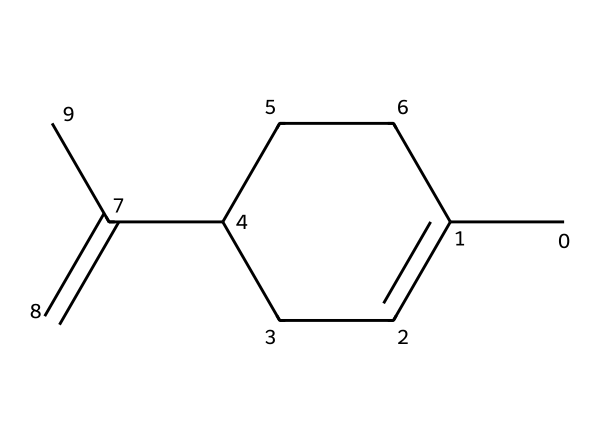What is the name of this compound? The SMILES representation corresponds to limonene, a well-known terpene found in citrus fruits, which is often associated with its characteristic citrus scent.
Answer: limonene How many carbon atoms are in limonene? Analyzing the structure based on the SMILES, there are a total of 10 carbon atoms present in the molecular structure of limonene.
Answer: 10 Is limonene chiral? The presence of a chiral center in the structure can be identified by looking for a carbon atom attached to four different substituents; limonene has one such carbon, confirming its chirality.
Answer: Yes What type of compound is limonene? Limonene is classified as a terpene, which is a category of compounds made primarily of carbon and hydrogen, commonly found in essential oils from plants.
Answer: terpene How many double bonds are present in limonene? The SMILES structure reveals that limonene contains two double bonds, which affect its chemical properties and reactivity.
Answer: 2 What functional group is present in limonene? Examining the structure, we can see that limonene does not contain an alcohol or carbonyl group; rather, it is a hydrocarbon with double bonds, characteristic of terpenes.
Answer: none What is the molecular formula of limonene? From counting the carbon and hydrogen atoms in the structure, the molecular formula can be derived as C10H16 for limonene.
Answer: C10H16 